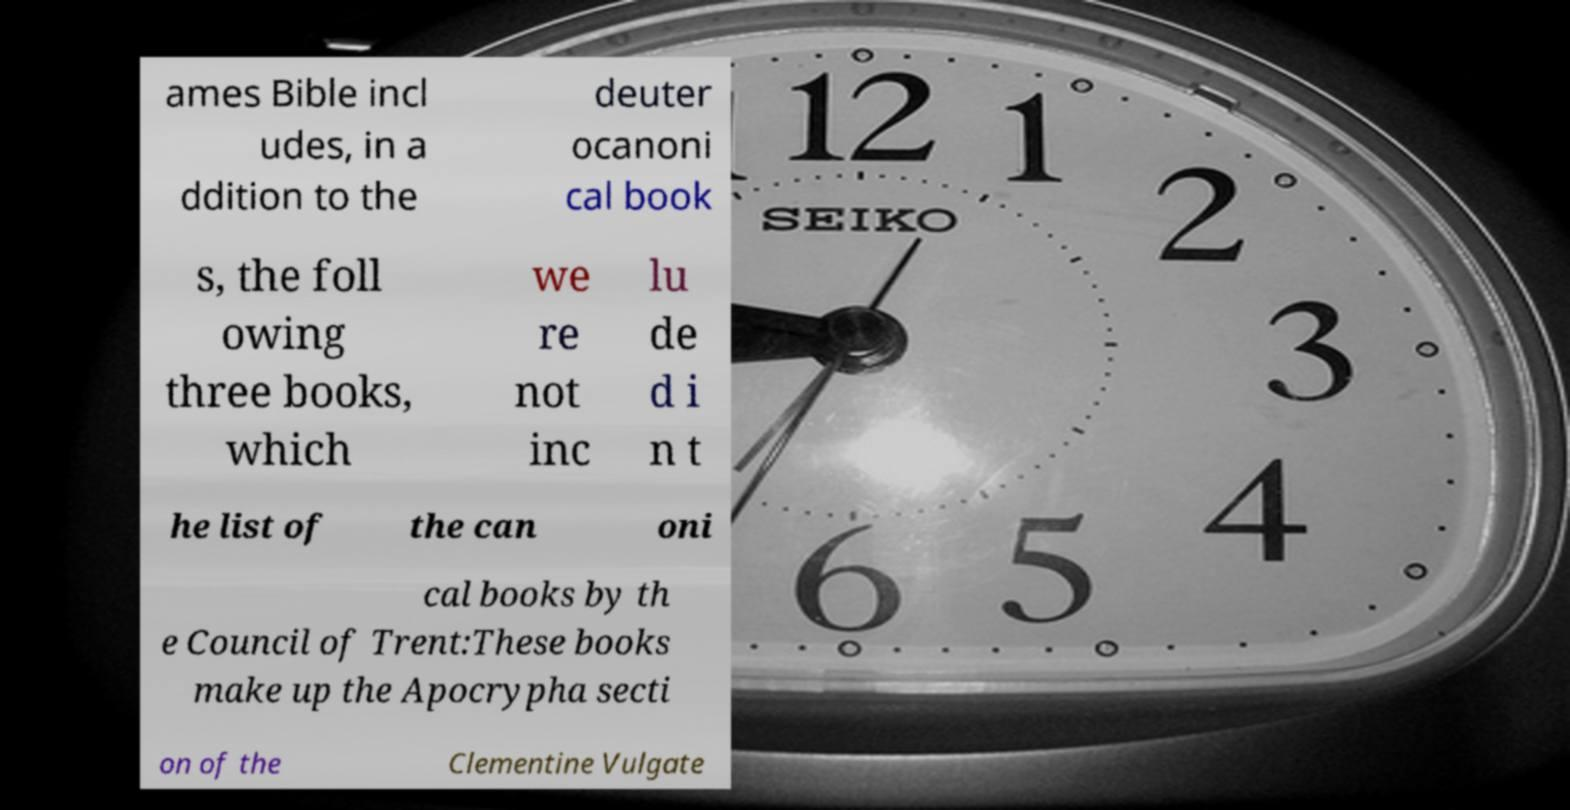Please identify and transcribe the text found in this image. ames Bible incl udes, in a ddition to the deuter ocanoni cal book s, the foll owing three books, which we re not inc lu de d i n t he list of the can oni cal books by th e Council of Trent:These books make up the Apocrypha secti on of the Clementine Vulgate 